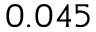<formula> <loc_0><loc_0><loc_500><loc_500>0 . 0 4 5</formula> 